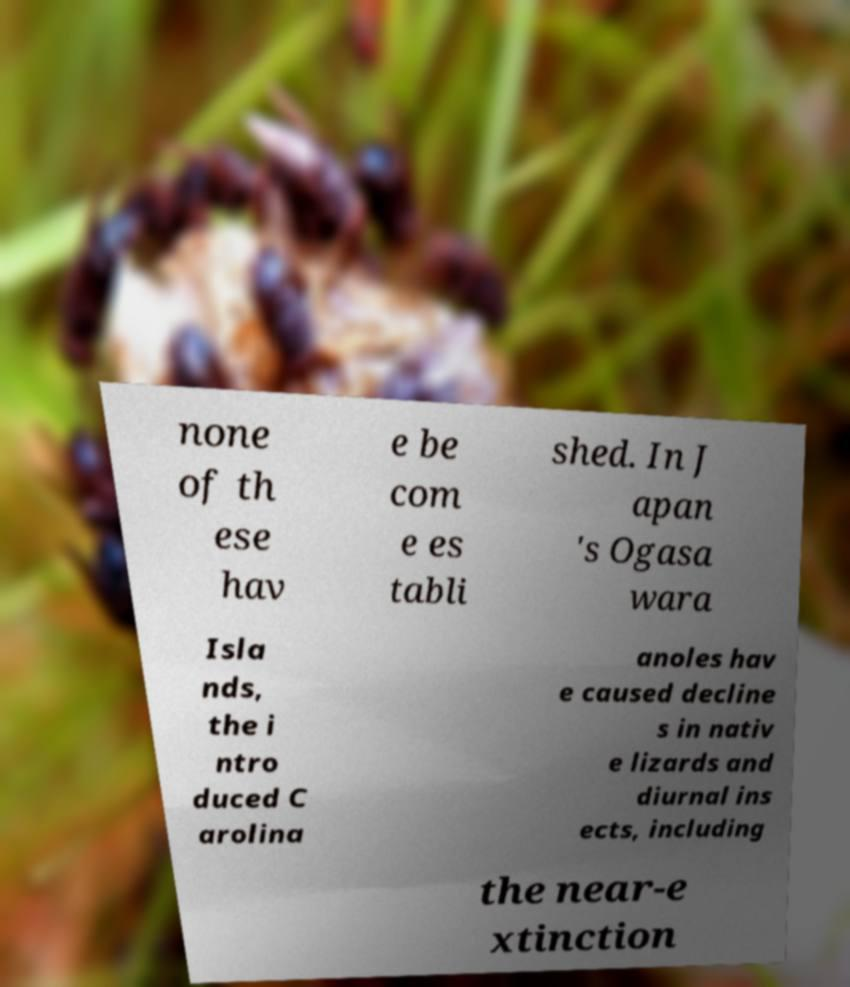Could you extract and type out the text from this image? none of th ese hav e be com e es tabli shed. In J apan 's Ogasa wara Isla nds, the i ntro duced C arolina anoles hav e caused decline s in nativ e lizards and diurnal ins ects, including the near-e xtinction 